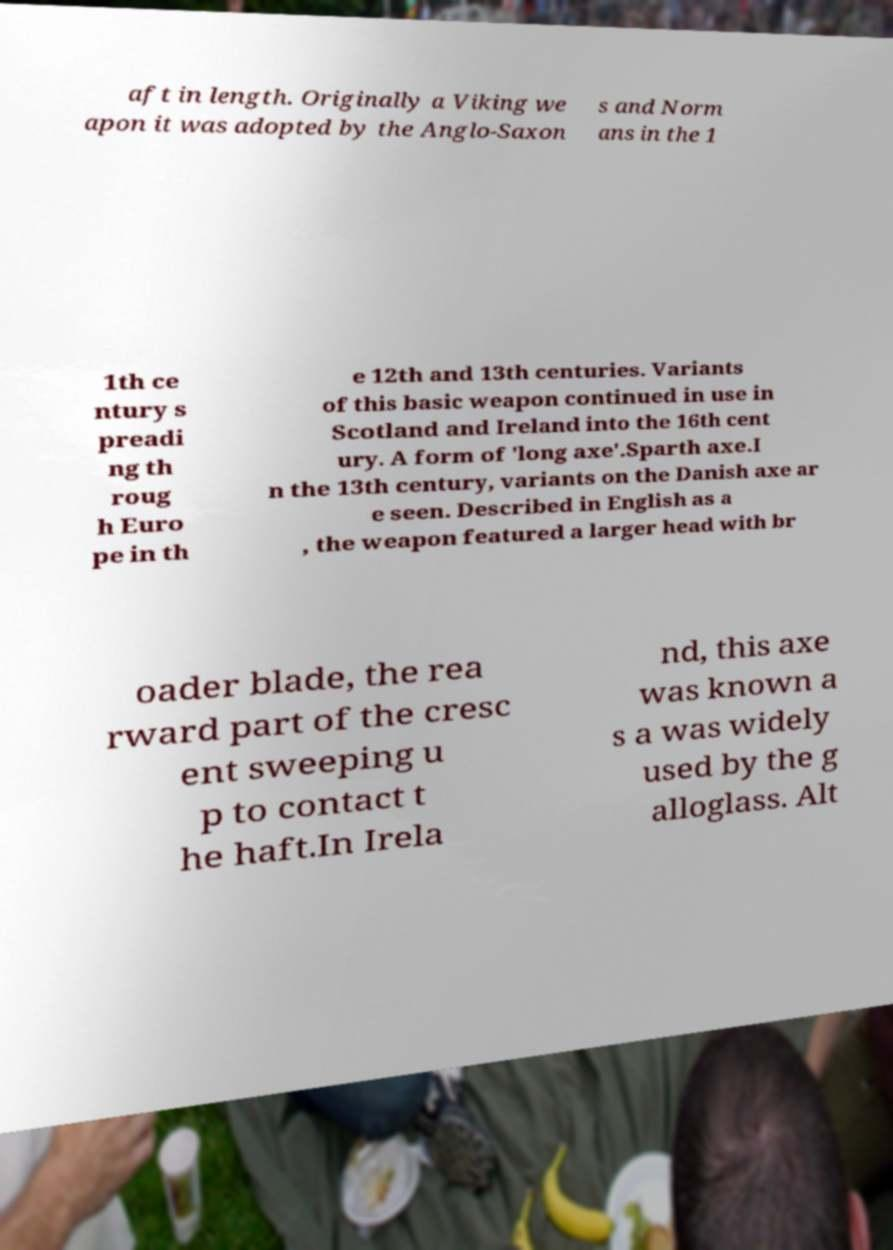Please read and relay the text visible in this image. What does it say? aft in length. Originally a Viking we apon it was adopted by the Anglo-Saxon s and Norm ans in the 1 1th ce ntury s preadi ng th roug h Euro pe in th e 12th and 13th centuries. Variants of this basic weapon continued in use in Scotland and Ireland into the 16th cent ury. A form of 'long axe'.Sparth axe.I n the 13th century, variants on the Danish axe ar e seen. Described in English as a , the weapon featured a larger head with br oader blade, the rea rward part of the cresc ent sweeping u p to contact t he haft.In Irela nd, this axe was known a s a was widely used by the g alloglass. Alt 